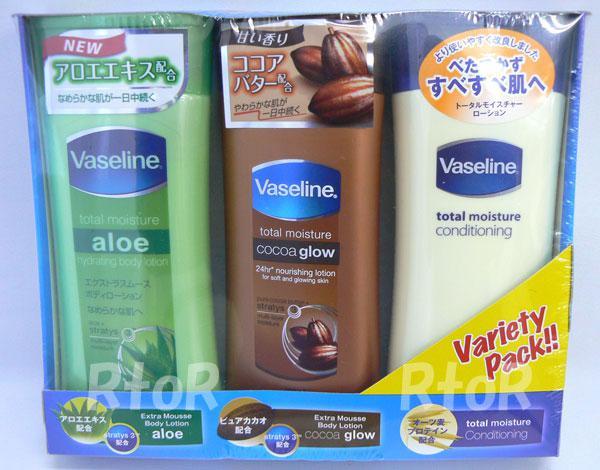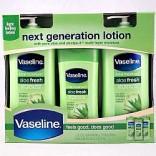The first image is the image on the left, the second image is the image on the right. Assess this claim about the two images: "The containers in the left image are all brown.". Correct or not? Answer yes or no. No. The first image is the image on the left, the second image is the image on the right. For the images displayed, is the sentence "Some bottles of Vaseline are still in the package." factually correct? Answer yes or no. Yes. 